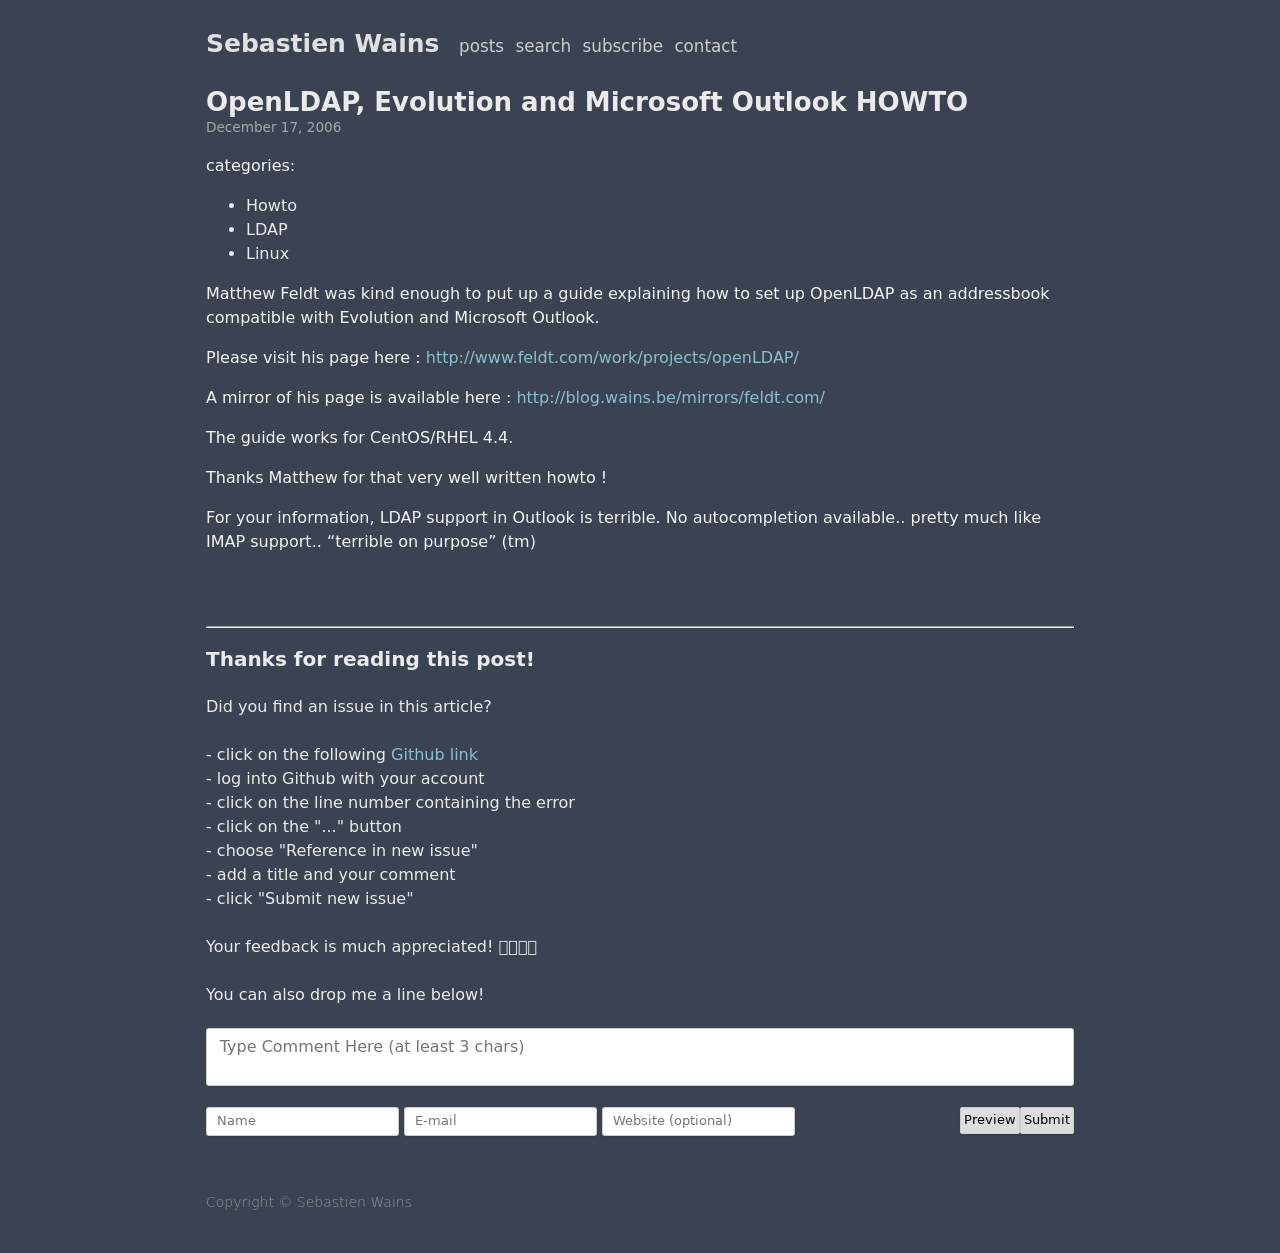How can I start building this website with HTML from the ground up? To start building a website with HTML from the ground up, begin by creating a basic HTML structure. Here's a simple template:

<!DOCTYPE html>
<html>
<head>
    <title>Your Website's Title</title>
</head>
<body>
    <h1>Welcome to My Website</h1>
    <p>This is a paragraph of text to get started.</p>
</body>
</html>

This code sets up the basic HTML document structure with a DOCTYPE declaration, an html tag to wrap everything, a head section for meta data like the title, and a body section where all visible content like headings, paragraphs, and images will go. 